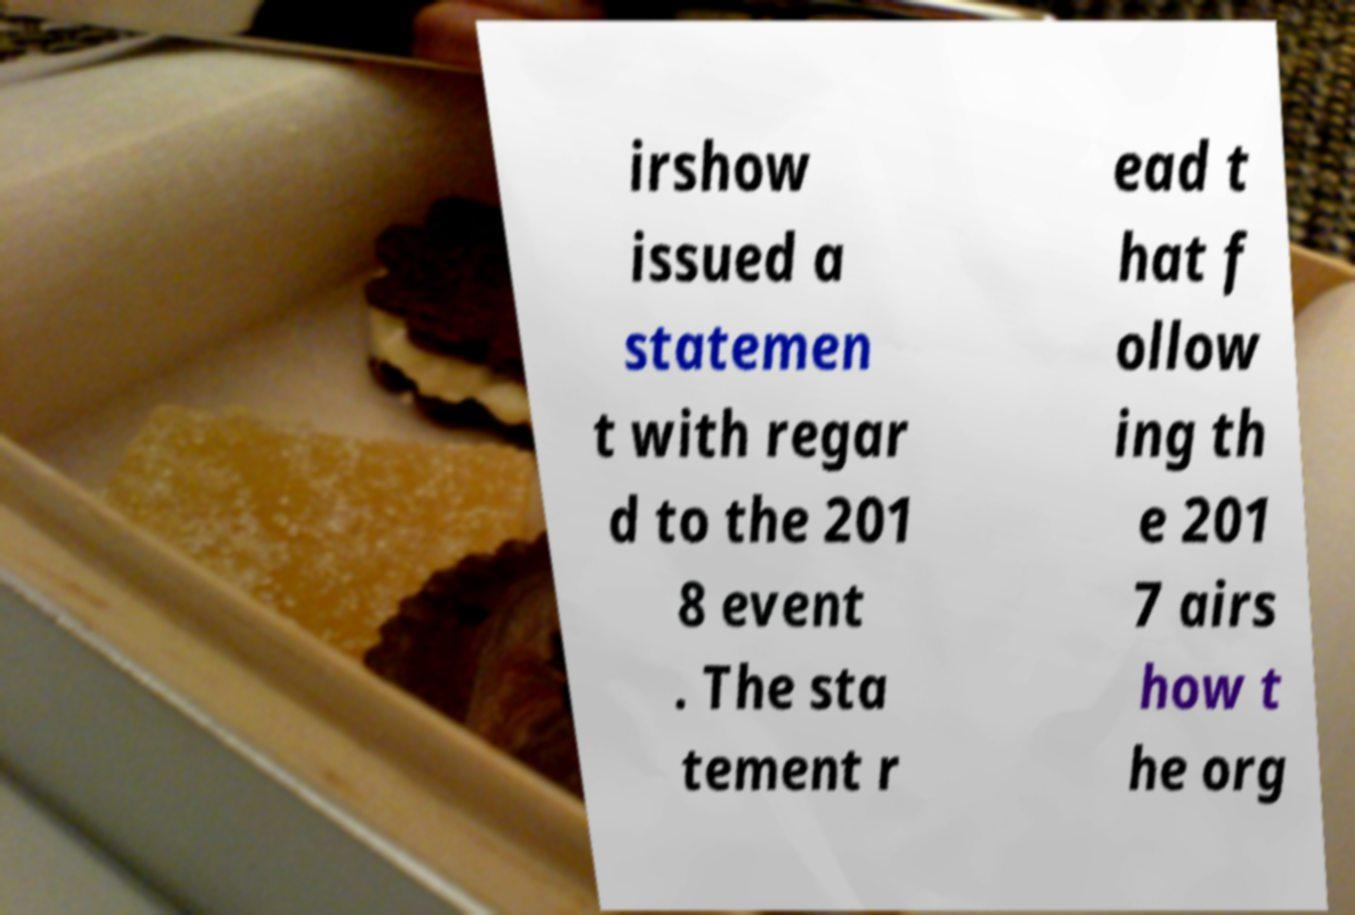Please identify and transcribe the text found in this image. irshow issued a statemen t with regar d to the 201 8 event . The sta tement r ead t hat f ollow ing th e 201 7 airs how t he org 